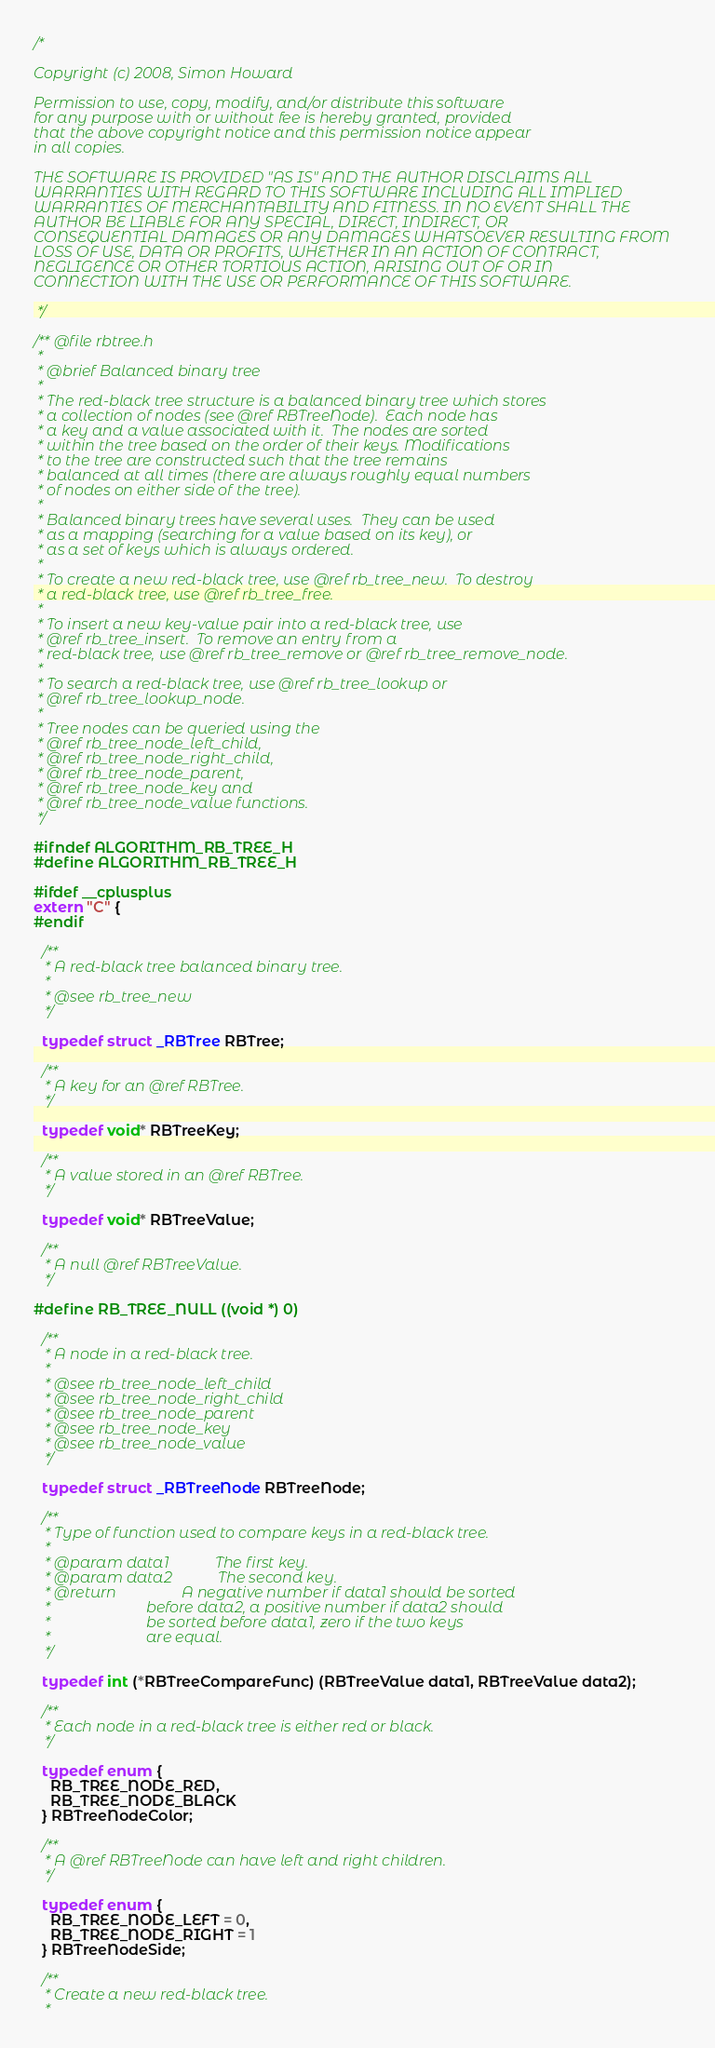Convert code to text. <code><loc_0><loc_0><loc_500><loc_500><_C_>/*

Copyright (c) 2008, Simon Howard

Permission to use, copy, modify, and/or distribute this software
for any purpose with or without fee is hereby granted, provided
that the above copyright notice and this permission notice appear
in all copies.

THE SOFTWARE IS PROVIDED "AS IS" AND THE AUTHOR DISCLAIMS ALL
WARRANTIES WITH REGARD TO THIS SOFTWARE INCLUDING ALL IMPLIED
WARRANTIES OF MERCHANTABILITY AND FITNESS. IN NO EVENT SHALL THE
AUTHOR BE LIABLE FOR ANY SPECIAL, DIRECT, INDIRECT, OR
CONSEQUENTIAL DAMAGES OR ANY DAMAGES WHATSOEVER RESULTING FROM
LOSS OF USE, DATA OR PROFITS, WHETHER IN AN ACTION OF CONTRACT,
NEGLIGENCE OR OTHER TORTIOUS ACTION, ARISING OUT OF OR IN
CONNECTION WITH THE USE OR PERFORMANCE OF THIS SOFTWARE.

 */

/** @file rbtree.h
 *
 * @brief Balanced binary tree
 *
 * The red-black tree structure is a balanced binary tree which stores
 * a collection of nodes (see @ref RBTreeNode).  Each node has
 * a key and a value associated with it.  The nodes are sorted
 * within the tree based on the order of their keys. Modifications
 * to the tree are constructed such that the tree remains
 * balanced at all times (there are always roughly equal numbers
 * of nodes on either side of the tree).
 *
 * Balanced binary trees have several uses.  They can be used
 * as a mapping (searching for a value based on its key), or
 * as a set of keys which is always ordered.
 *
 * To create a new red-black tree, use @ref rb_tree_new.  To destroy
 * a red-black tree, use @ref rb_tree_free.
 *
 * To insert a new key-value pair into a red-black tree, use
 * @ref rb_tree_insert.  To remove an entry from a
 * red-black tree, use @ref rb_tree_remove or @ref rb_tree_remove_node.
 *
 * To search a red-black tree, use @ref rb_tree_lookup or
 * @ref rb_tree_lookup_node.
 *
 * Tree nodes can be queried using the
 * @ref rb_tree_node_left_child,
 * @ref rb_tree_node_right_child,
 * @ref rb_tree_node_parent,
 * @ref rb_tree_node_key and
 * @ref rb_tree_node_value functions.
 */

#ifndef ALGORITHM_RB_TREE_H
#define ALGORITHM_RB_TREE_H

#ifdef __cplusplus
extern "C" {
#endif

  /**
   * A red-black tree balanced binary tree.
   *
   * @see rb_tree_new
   */

  typedef struct _RBTree RBTree;

  /**
   * A key for an @ref RBTree.
   */

  typedef void* RBTreeKey;

  /**
   * A value stored in an @ref RBTree.
   */

  typedef void* RBTreeValue;

  /**
   * A null @ref RBTreeValue.
   */

#define RB_TREE_NULL ((void *) 0)

  /**
   * A node in a red-black tree.
   *
   * @see rb_tree_node_left_child
   * @see rb_tree_node_right_child
   * @see rb_tree_node_parent
   * @see rb_tree_node_key
   * @see rb_tree_node_value
   */

  typedef struct _RBTreeNode RBTreeNode;

  /**
   * Type of function used to compare keys in a red-black tree.
   *
   * @param data1            The first key.
   * @param data2            The second key.
   * @return                 A negative number if data1 should be sorted
   *                         before data2, a positive number if data2 should
   *                         be sorted before data1, zero if the two keys
   *                         are equal.
   */

  typedef int (*RBTreeCompareFunc) (RBTreeValue data1, RBTreeValue data2);

  /**
   * Each node in a red-black tree is either red or black.
   */

  typedef enum {
    RB_TREE_NODE_RED,
    RB_TREE_NODE_BLACK
  } RBTreeNodeColor;

  /**
   * A @ref RBTreeNode can have left and right children.
   */

  typedef enum {
    RB_TREE_NODE_LEFT = 0,
    RB_TREE_NODE_RIGHT = 1
  } RBTreeNodeSide;

  /**
   * Create a new red-black tree.
   *</code> 